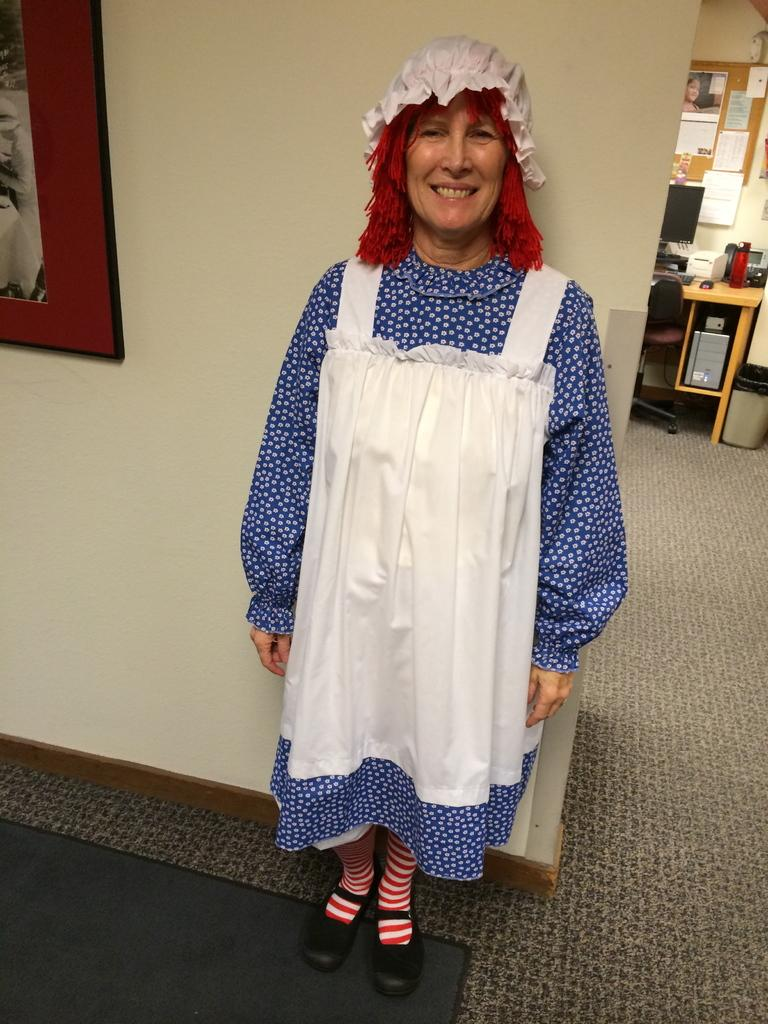What is the main subject of the image? There is a person standing in the center of the image. What is the person's expression in the image? The person is smiling. What can be seen in the background of the image? There is a wall, a photo frame, a table, a bottle, a monitor, a dustbin, a notice board, a chair, and a carpet visible in the background of the image. What time of day is it in the image, and is there a playground nearby? The time of day cannot be determined from the image, and there is no mention of a playground in the provided facts. How many toes can be seen on the person's feet in the image? The image does not show the person's feet, so the number of toes cannot be determined. 